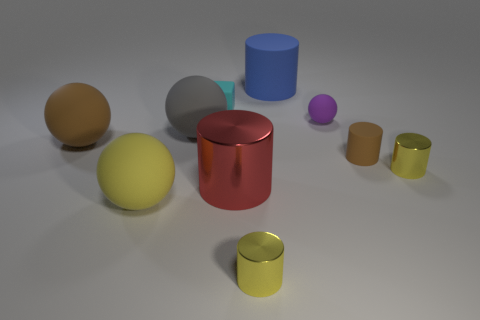What color is the rubber cube?
Offer a very short reply. Cyan. There is a large brown rubber sphere in front of the purple object; are there any large brown rubber balls that are left of it?
Offer a very short reply. No. The small yellow thing left of the small yellow shiny cylinder to the right of the small rubber cylinder is what shape?
Offer a terse response. Cylinder. Is the number of rubber cylinders less than the number of large objects?
Make the answer very short. Yes. Are the tiny brown object and the yellow ball made of the same material?
Your response must be concise. Yes. What color is the thing that is behind the small purple matte object and left of the red shiny thing?
Offer a very short reply. Cyan. Is there a green matte ball of the same size as the purple rubber sphere?
Offer a very short reply. No. There is a metallic thing right of the brown thing right of the brown matte sphere; what size is it?
Your response must be concise. Small. Is the number of big brown things on the right side of the cyan block less than the number of tiny green matte objects?
Provide a succinct answer. No. Is the small ball the same color as the tiny rubber cylinder?
Ensure brevity in your answer.  No. 